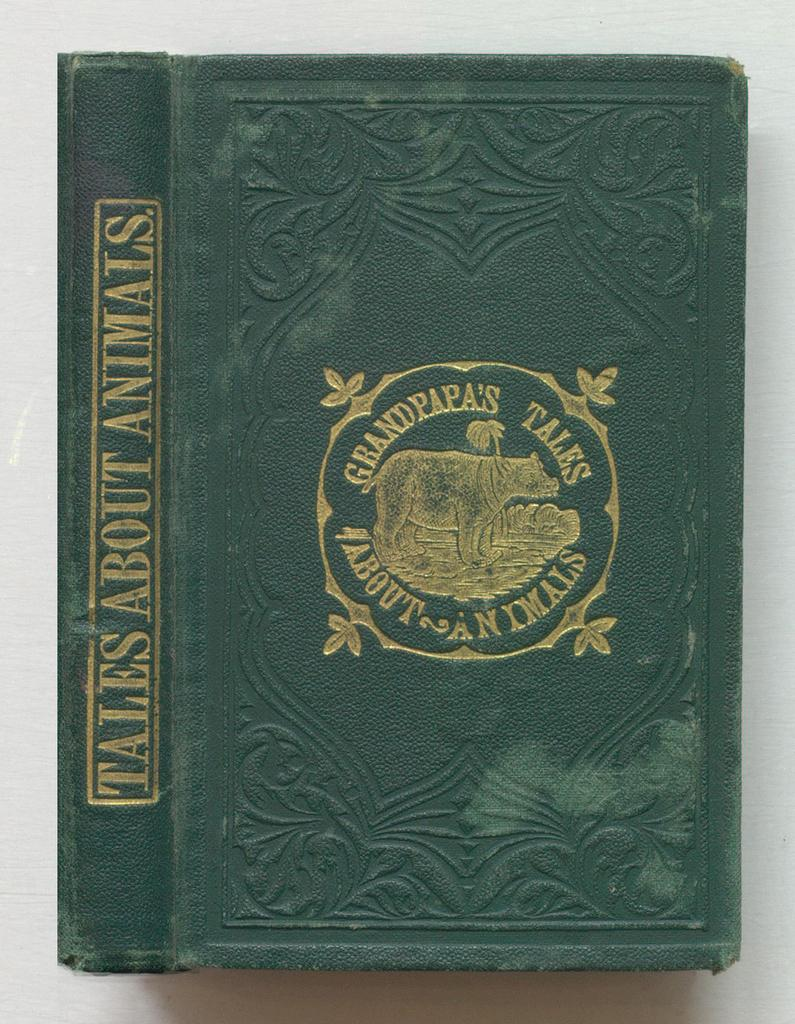<image>
Relay a brief, clear account of the picture shown. A first edition of tales about animals has been placed on the table 